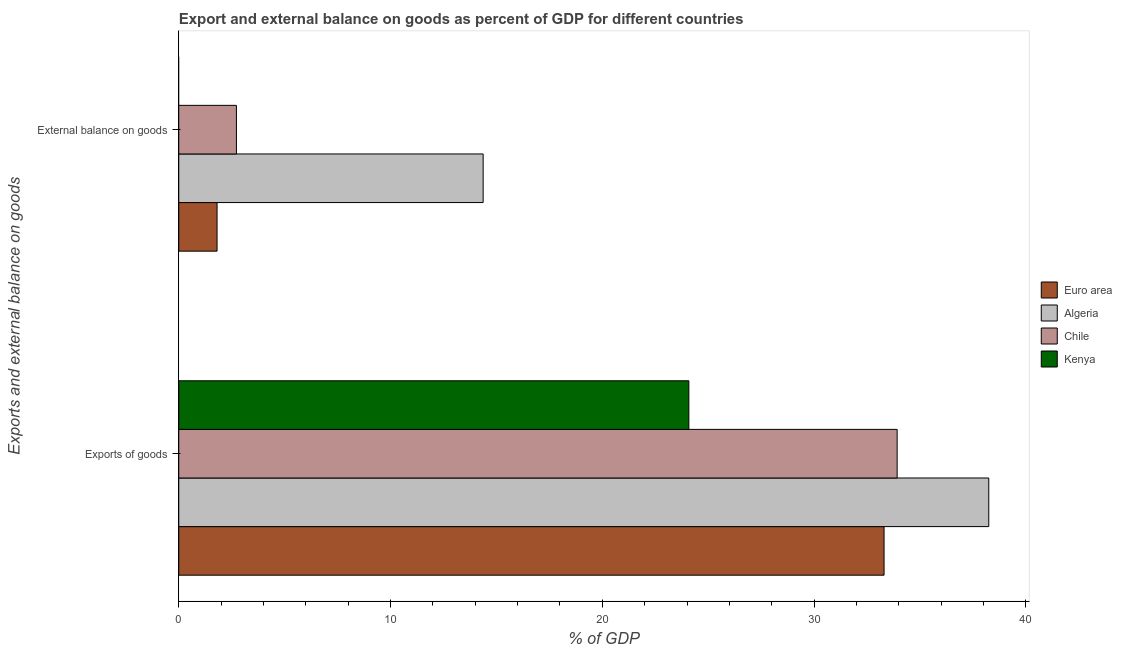How many groups of bars are there?
Your answer should be very brief. 2. Are the number of bars per tick equal to the number of legend labels?
Your response must be concise. No. How many bars are there on the 2nd tick from the top?
Keep it short and to the point. 4. What is the label of the 1st group of bars from the top?
Provide a succinct answer. External balance on goods. What is the export of goods as percentage of gdp in Kenya?
Give a very brief answer. 24.09. Across all countries, what is the maximum external balance on goods as percentage of gdp?
Make the answer very short. 14.37. Across all countries, what is the minimum export of goods as percentage of gdp?
Your response must be concise. 24.09. In which country was the external balance on goods as percentage of gdp maximum?
Offer a very short reply. Algeria. What is the total external balance on goods as percentage of gdp in the graph?
Provide a short and direct response. 18.9. What is the difference between the export of goods as percentage of gdp in Kenya and that in Euro area?
Provide a short and direct response. -9.22. What is the difference between the external balance on goods as percentage of gdp in Algeria and the export of goods as percentage of gdp in Euro area?
Give a very brief answer. -18.93. What is the average export of goods as percentage of gdp per country?
Ensure brevity in your answer.  32.39. What is the difference between the external balance on goods as percentage of gdp and export of goods as percentage of gdp in Chile?
Ensure brevity in your answer.  -31.2. What is the ratio of the export of goods as percentage of gdp in Kenya to that in Euro area?
Your response must be concise. 0.72. In how many countries, is the export of goods as percentage of gdp greater than the average export of goods as percentage of gdp taken over all countries?
Give a very brief answer. 3. Are all the bars in the graph horizontal?
Provide a short and direct response. Yes. How many countries are there in the graph?
Keep it short and to the point. 4. Are the values on the major ticks of X-axis written in scientific E-notation?
Your response must be concise. No. Does the graph contain grids?
Offer a terse response. No. How many legend labels are there?
Keep it short and to the point. 4. What is the title of the graph?
Keep it short and to the point. Export and external balance on goods as percent of GDP for different countries. What is the label or title of the X-axis?
Keep it short and to the point. % of GDP. What is the label or title of the Y-axis?
Offer a very short reply. Exports and external balance on goods. What is the % of GDP of Euro area in Exports of goods?
Your response must be concise. 33.31. What is the % of GDP in Algeria in Exports of goods?
Keep it short and to the point. 38.25. What is the % of GDP in Chile in Exports of goods?
Your answer should be very brief. 33.92. What is the % of GDP in Kenya in Exports of goods?
Make the answer very short. 24.09. What is the % of GDP of Euro area in External balance on goods?
Provide a succinct answer. 1.81. What is the % of GDP in Algeria in External balance on goods?
Provide a succinct answer. 14.37. What is the % of GDP of Chile in External balance on goods?
Make the answer very short. 2.72. Across all Exports and external balance on goods, what is the maximum % of GDP of Euro area?
Make the answer very short. 33.31. Across all Exports and external balance on goods, what is the maximum % of GDP of Algeria?
Your answer should be very brief. 38.25. Across all Exports and external balance on goods, what is the maximum % of GDP of Chile?
Your response must be concise. 33.92. Across all Exports and external balance on goods, what is the maximum % of GDP of Kenya?
Offer a terse response. 24.09. Across all Exports and external balance on goods, what is the minimum % of GDP in Euro area?
Provide a succinct answer. 1.81. Across all Exports and external balance on goods, what is the minimum % of GDP of Algeria?
Give a very brief answer. 14.37. Across all Exports and external balance on goods, what is the minimum % of GDP of Chile?
Give a very brief answer. 2.72. Across all Exports and external balance on goods, what is the minimum % of GDP of Kenya?
Provide a succinct answer. 0. What is the total % of GDP in Euro area in the graph?
Provide a succinct answer. 35.11. What is the total % of GDP of Algeria in the graph?
Offer a very short reply. 52.62. What is the total % of GDP in Chile in the graph?
Provide a succinct answer. 36.64. What is the total % of GDP in Kenya in the graph?
Your response must be concise. 24.09. What is the difference between the % of GDP of Euro area in Exports of goods and that in External balance on goods?
Your response must be concise. 31.5. What is the difference between the % of GDP of Algeria in Exports of goods and that in External balance on goods?
Your answer should be compact. 23.88. What is the difference between the % of GDP of Chile in Exports of goods and that in External balance on goods?
Provide a short and direct response. 31.2. What is the difference between the % of GDP in Euro area in Exports of goods and the % of GDP in Algeria in External balance on goods?
Your answer should be compact. 18.93. What is the difference between the % of GDP of Euro area in Exports of goods and the % of GDP of Chile in External balance on goods?
Your answer should be compact. 30.58. What is the difference between the % of GDP of Algeria in Exports of goods and the % of GDP of Chile in External balance on goods?
Make the answer very short. 35.53. What is the average % of GDP in Euro area per Exports and external balance on goods?
Give a very brief answer. 17.56. What is the average % of GDP of Algeria per Exports and external balance on goods?
Offer a very short reply. 26.31. What is the average % of GDP in Chile per Exports and external balance on goods?
Make the answer very short. 18.32. What is the average % of GDP in Kenya per Exports and external balance on goods?
Keep it short and to the point. 12.04. What is the difference between the % of GDP in Euro area and % of GDP in Algeria in Exports of goods?
Your response must be concise. -4.94. What is the difference between the % of GDP in Euro area and % of GDP in Chile in Exports of goods?
Your answer should be compact. -0.62. What is the difference between the % of GDP of Euro area and % of GDP of Kenya in Exports of goods?
Your response must be concise. 9.22. What is the difference between the % of GDP in Algeria and % of GDP in Chile in Exports of goods?
Offer a very short reply. 4.33. What is the difference between the % of GDP in Algeria and % of GDP in Kenya in Exports of goods?
Ensure brevity in your answer.  14.16. What is the difference between the % of GDP of Chile and % of GDP of Kenya in Exports of goods?
Make the answer very short. 9.84. What is the difference between the % of GDP in Euro area and % of GDP in Algeria in External balance on goods?
Ensure brevity in your answer.  -12.56. What is the difference between the % of GDP of Euro area and % of GDP of Chile in External balance on goods?
Provide a short and direct response. -0.91. What is the difference between the % of GDP in Algeria and % of GDP in Chile in External balance on goods?
Give a very brief answer. 11.65. What is the ratio of the % of GDP of Euro area in Exports of goods to that in External balance on goods?
Your answer should be compact. 18.42. What is the ratio of the % of GDP in Algeria in Exports of goods to that in External balance on goods?
Make the answer very short. 2.66. What is the ratio of the % of GDP in Chile in Exports of goods to that in External balance on goods?
Offer a very short reply. 12.46. What is the difference between the highest and the second highest % of GDP of Euro area?
Your answer should be very brief. 31.5. What is the difference between the highest and the second highest % of GDP in Algeria?
Ensure brevity in your answer.  23.88. What is the difference between the highest and the second highest % of GDP of Chile?
Keep it short and to the point. 31.2. What is the difference between the highest and the lowest % of GDP of Euro area?
Provide a succinct answer. 31.5. What is the difference between the highest and the lowest % of GDP of Algeria?
Make the answer very short. 23.88. What is the difference between the highest and the lowest % of GDP in Chile?
Make the answer very short. 31.2. What is the difference between the highest and the lowest % of GDP of Kenya?
Ensure brevity in your answer.  24.09. 